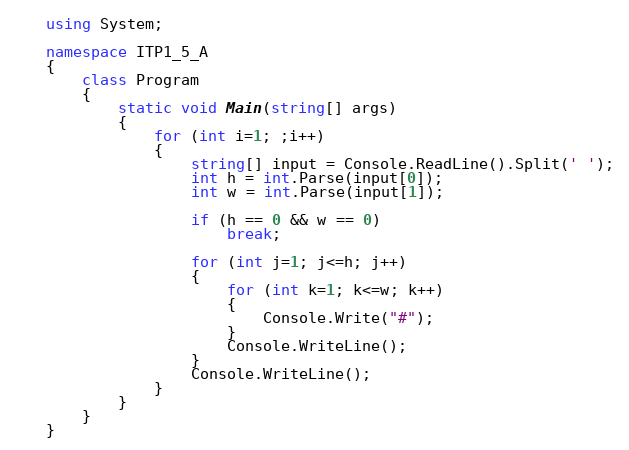<code> <loc_0><loc_0><loc_500><loc_500><_C#_>using System;

namespace ITP1_5_A
{
    class Program
    {
        static void Main(string[] args)
        {
            for (int i=1; ;i++)
            {
                string[] input = Console.ReadLine().Split(' ');
                int h = int.Parse(input[0]);
                int w = int.Parse(input[1]);

                if (h == 0 && w == 0)
                    break;

                for (int j=1; j<=h; j++)
                {
                    for (int k=1; k<=w; k++)
                    {
                        Console.Write("#");
                    }
                    Console.WriteLine();
                }
                Console.WriteLine();
            }
        }
    }
}</code> 